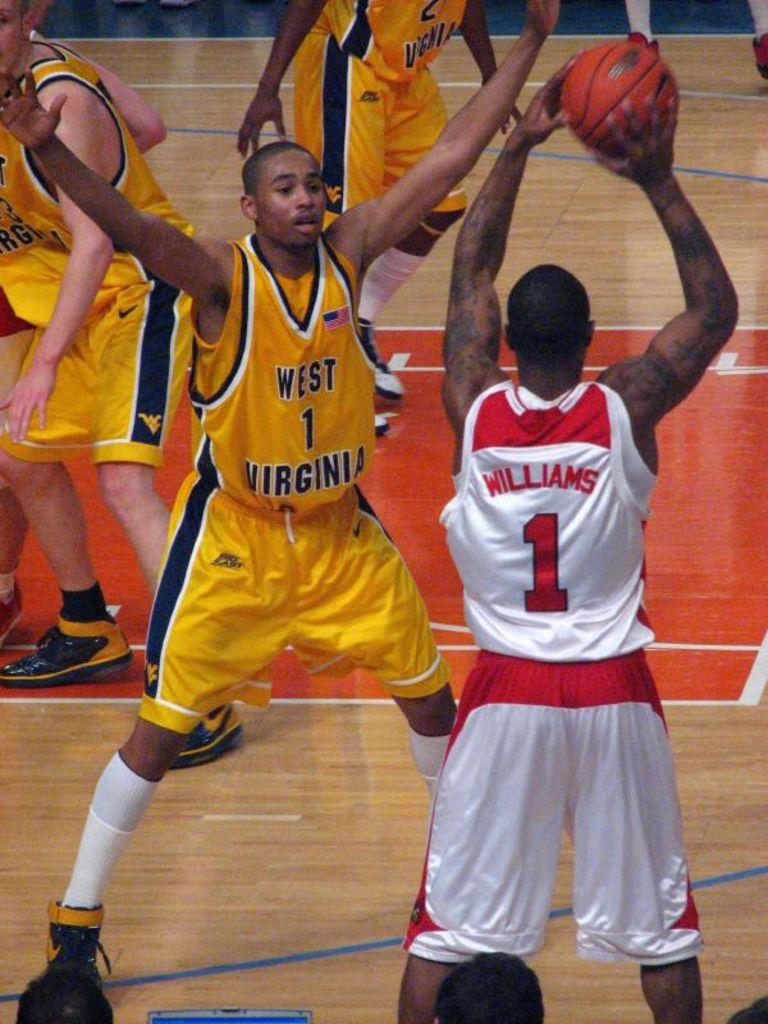<image>
Present a compact description of the photo's key features. a few players playing basketball with one wearing the number 1 